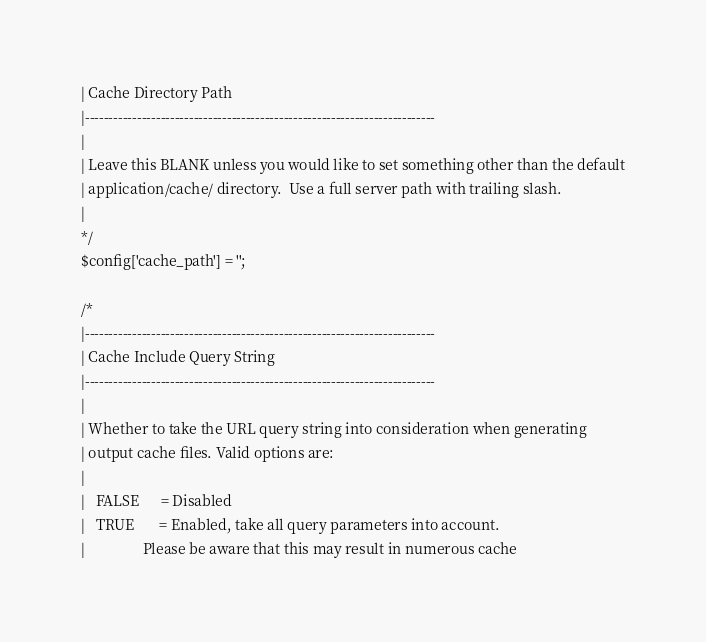<code> <loc_0><loc_0><loc_500><loc_500><_PHP_>| Cache Directory Path
|--------------------------------------------------------------------------
|
| Leave this BLANK unless you would like to set something other than the default
| application/cache/ directory.  Use a full server path with trailing slash.
|
*/
$config['cache_path'] = '';

/*
|--------------------------------------------------------------------------
| Cache Include Query String
|--------------------------------------------------------------------------
|
| Whether to take the URL query string into consideration when generating
| output cache files. Valid options are:
|
|	FALSE      = Disabled
|	TRUE       = Enabled, take all query parameters into account.
|	             Please be aware that this may result in numerous cache</code> 